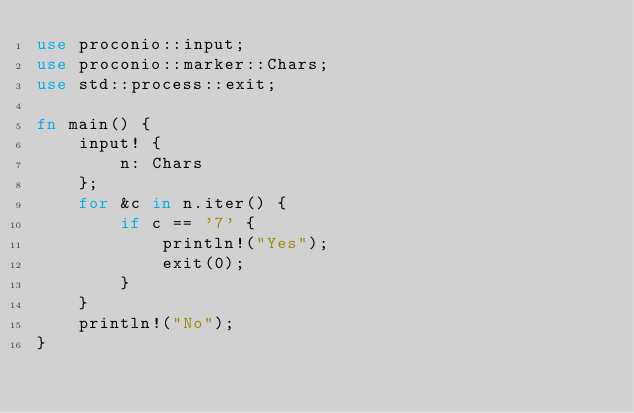Convert code to text. <code><loc_0><loc_0><loc_500><loc_500><_Rust_>use proconio::input;
use proconio::marker::Chars;
use std::process::exit;

fn main() {
    input! {
        n: Chars
    };
    for &c in n.iter() {
        if c == '7' {
            println!("Yes");
            exit(0);
        }
    }
    println!("No");
}
</code> 